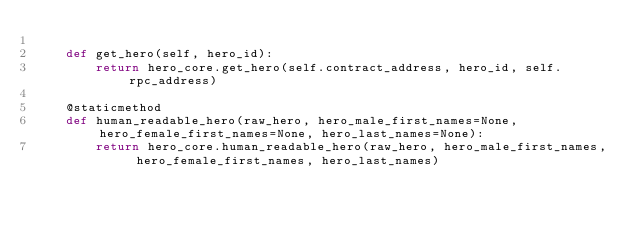Convert code to text. <code><loc_0><loc_0><loc_500><loc_500><_Python_>
    def get_hero(self, hero_id):
        return hero_core.get_hero(self.contract_address, hero_id, self.rpc_address)

    @staticmethod
    def human_readable_hero(raw_hero, hero_male_first_names=None, hero_female_first_names=None, hero_last_names=None):
        return hero_core.human_readable_hero(raw_hero, hero_male_first_names, hero_female_first_names, hero_last_names)
</code> 